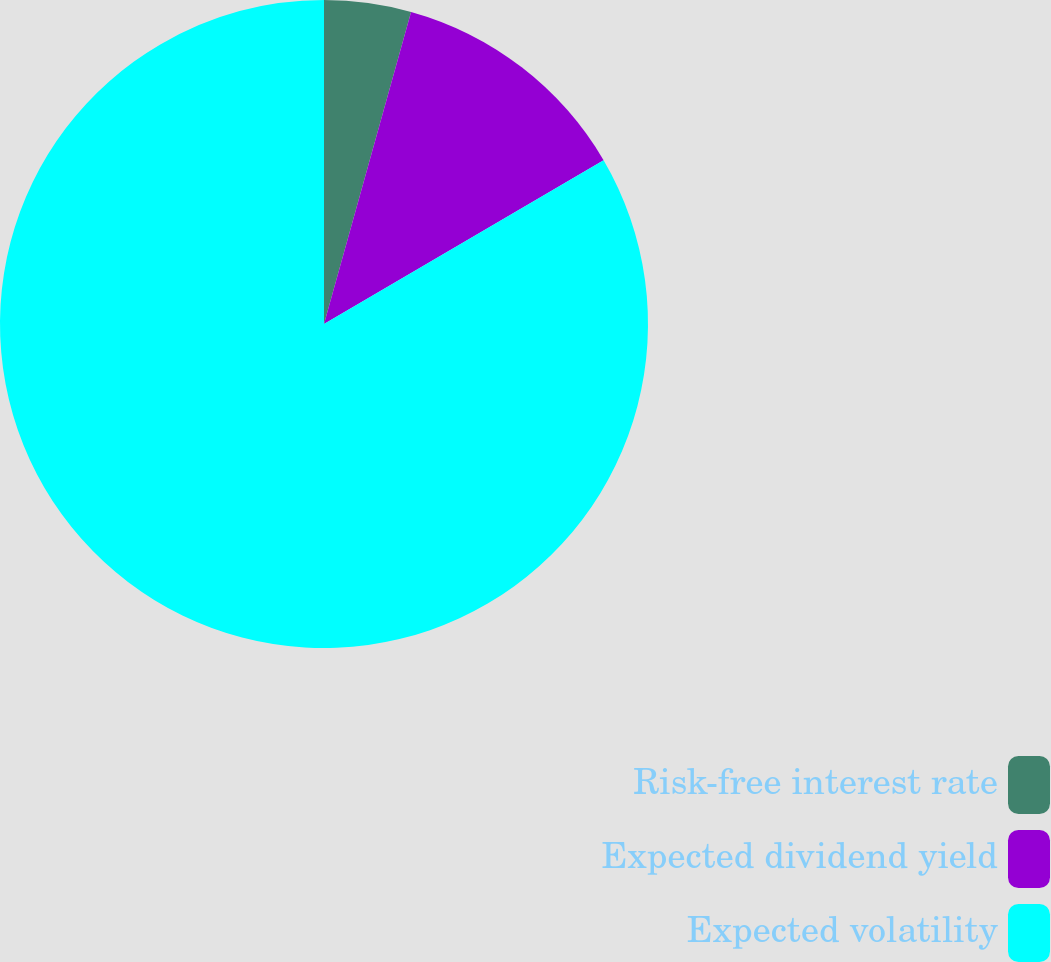<chart> <loc_0><loc_0><loc_500><loc_500><pie_chart><fcel>Risk-free interest rate<fcel>Expected dividend yield<fcel>Expected volatility<nl><fcel>4.33%<fcel>12.24%<fcel>83.43%<nl></chart> 